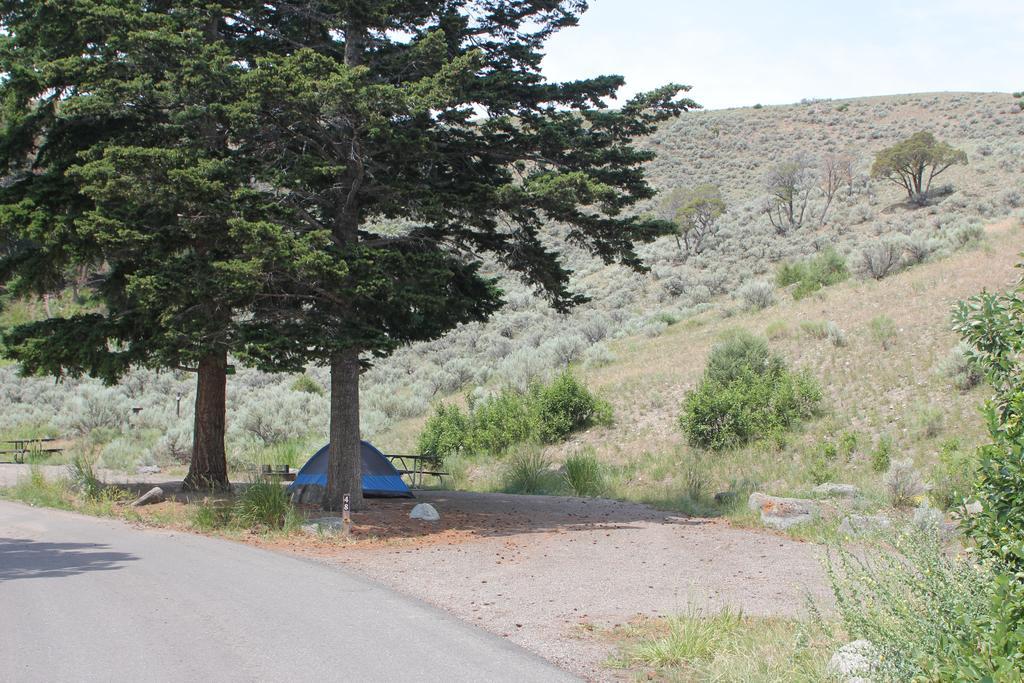Describe this image in one or two sentences. In this picture I can see trees and few plants on the ground and looks like a tent on the ground and couple of benches and I can see a cloudy sky. 